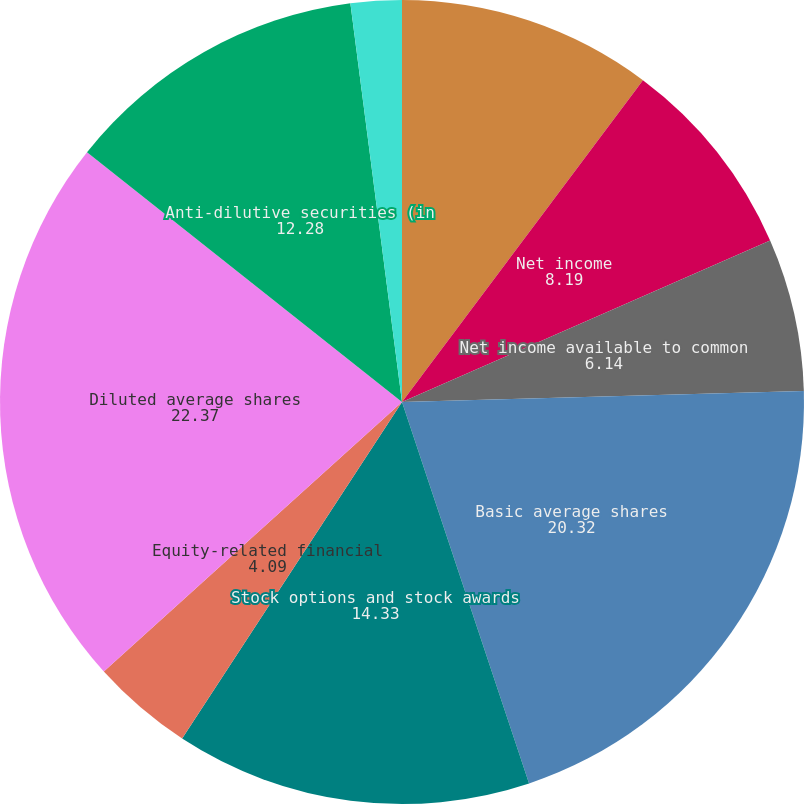<chart> <loc_0><loc_0><loc_500><loc_500><pie_chart><fcel>(Dollars in millions except<fcel>Net income<fcel>Net income available to common<fcel>Basic average shares<fcel>Stock options and stock awards<fcel>Equity-related financial<fcel>Diluted average shares<fcel>Anti-dilutive securities (in<fcel>Basic<fcel>Diluted<nl><fcel>10.23%<fcel>8.19%<fcel>6.14%<fcel>20.32%<fcel>14.33%<fcel>4.09%<fcel>22.37%<fcel>12.28%<fcel>2.05%<fcel>0.0%<nl></chart> 